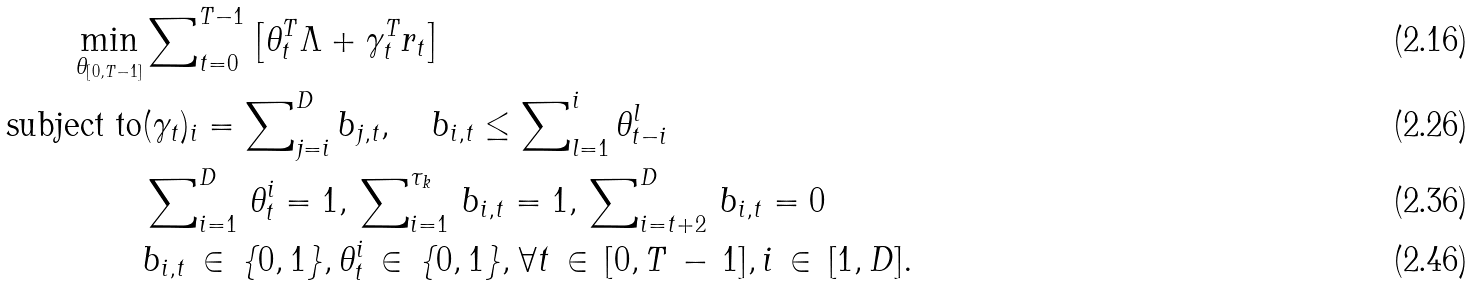Convert formula to latex. <formula><loc_0><loc_0><loc_500><loc_500>\min _ { \theta _ { [ 0 , T - 1 ] } } & \sum \nolimits _ { t = 0 } ^ { T - 1 } \left [ \theta _ { t } ^ { T } \Lambda + \gamma _ { t } ^ { T } r _ { t } \right ] \\ \text {subject to} & ( \gamma _ { t } ) _ { i } = \sum \nolimits _ { j = i } ^ { D } b _ { j , t } , \quad b _ { i , t } \leq \sum \nolimits _ { l = 1 } ^ { i } \theta _ { t - i } ^ { l } \\ & \sum \nolimits _ { i = 1 } ^ { D } \, \theta _ { t } ^ { i } = 1 , \, \sum \nolimits _ { i = 1 } ^ { \tau _ { k } } \, b _ { i , t } = 1 , \, \sum \nolimits _ { i = t + 2 } ^ { D } \, b _ { i , t } = 0 \\ & b _ { i , t } \, \in \, \{ 0 , 1 \} , \theta _ { t } ^ { i } \, \in \, \{ 0 , 1 \} , \forall t \, \in \, [ 0 , T \, - \, 1 ] , i \, \in \, [ 1 , D ] .</formula> 